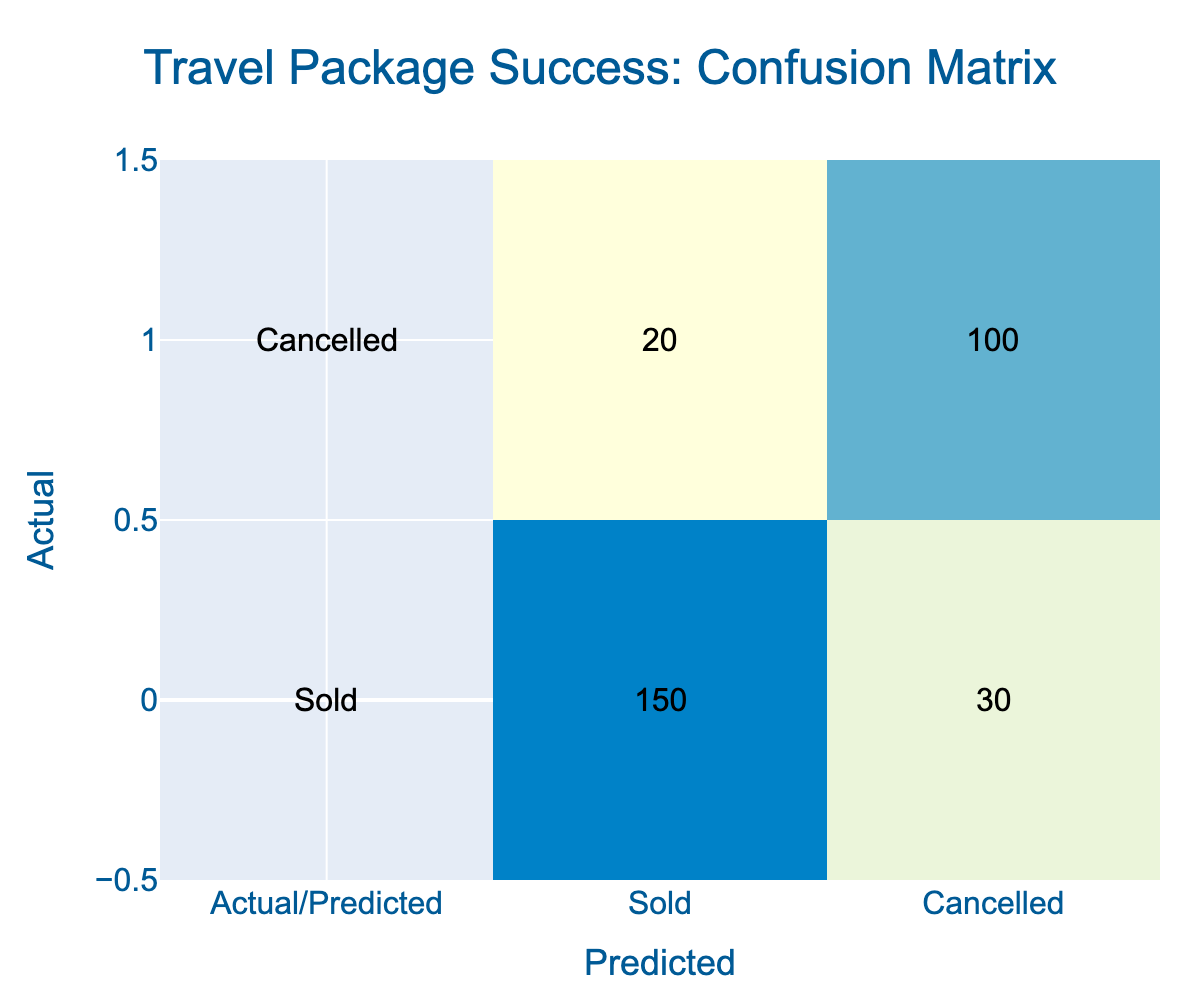What is the total number of sold packages? To find the total number of sold packages, we look at the "Sold" row and total the values: 150 (sold) + 30 (cancelled) = 180.
Answer: 180 How many packages were actually cancelled? The actual cancelled packages are represented in the row labeled "Cancelled." The value here is 100, which indicates the number of packages that were actually cancelled.
Answer: 100 What percentage of sold packages were actually sold? To find the percentage of sold packages that were actually sold, we take the number of sold packages (150) and divide it by the total number of predicted sold packages (150 + 30 = 180). The calculation is (150/180) * 100 = 83.33%.
Answer: 83.33% How many packages were incorrectly predicted as sold? The packages that were incorrectly predicted as sold can be found in the "Cancelled" row under the "Sold" column, which amounts to 20 packages.
Answer: 20 How many total packages were analyzed? To find the total number of packages analyzed, we total all values in the confusion matrix. This is 150 (sold) + 30 (cancelled) + 20 (incorrectly predicted as sold) + 100 (actually cancelled) = 300.
Answer: 300 Were more packages cancelled than sold? By examining the total number of sold packages (180) and the packages that were cancelled (120), it can be seen that 120 is less than 180, so the statement is false.
Answer: No What is the difference between the number of correctly predicted sold packages and correctly predicted cancelled packages? The correctly predicted sold packages amount to 150, and the correctly predicted cancelled packages amount to 100. The difference is calculated as 150 - 100 = 50.
Answer: 50 What proportion of the total is represented by cancelled packages? To find the proportion of cancelled packages, we take the number of cancelled packages (120) and divide it by the total number analyzed (300). Thus, the proportion is 120/300 = 0.4 or 40%.
Answer: 40% How many packages were misclassified as cancelled? The misclassified packages that were predicted as cancelled but were actually sold are found in the "Cancelled" row and "Sold" column, which is 30 packages.
Answer: 30 